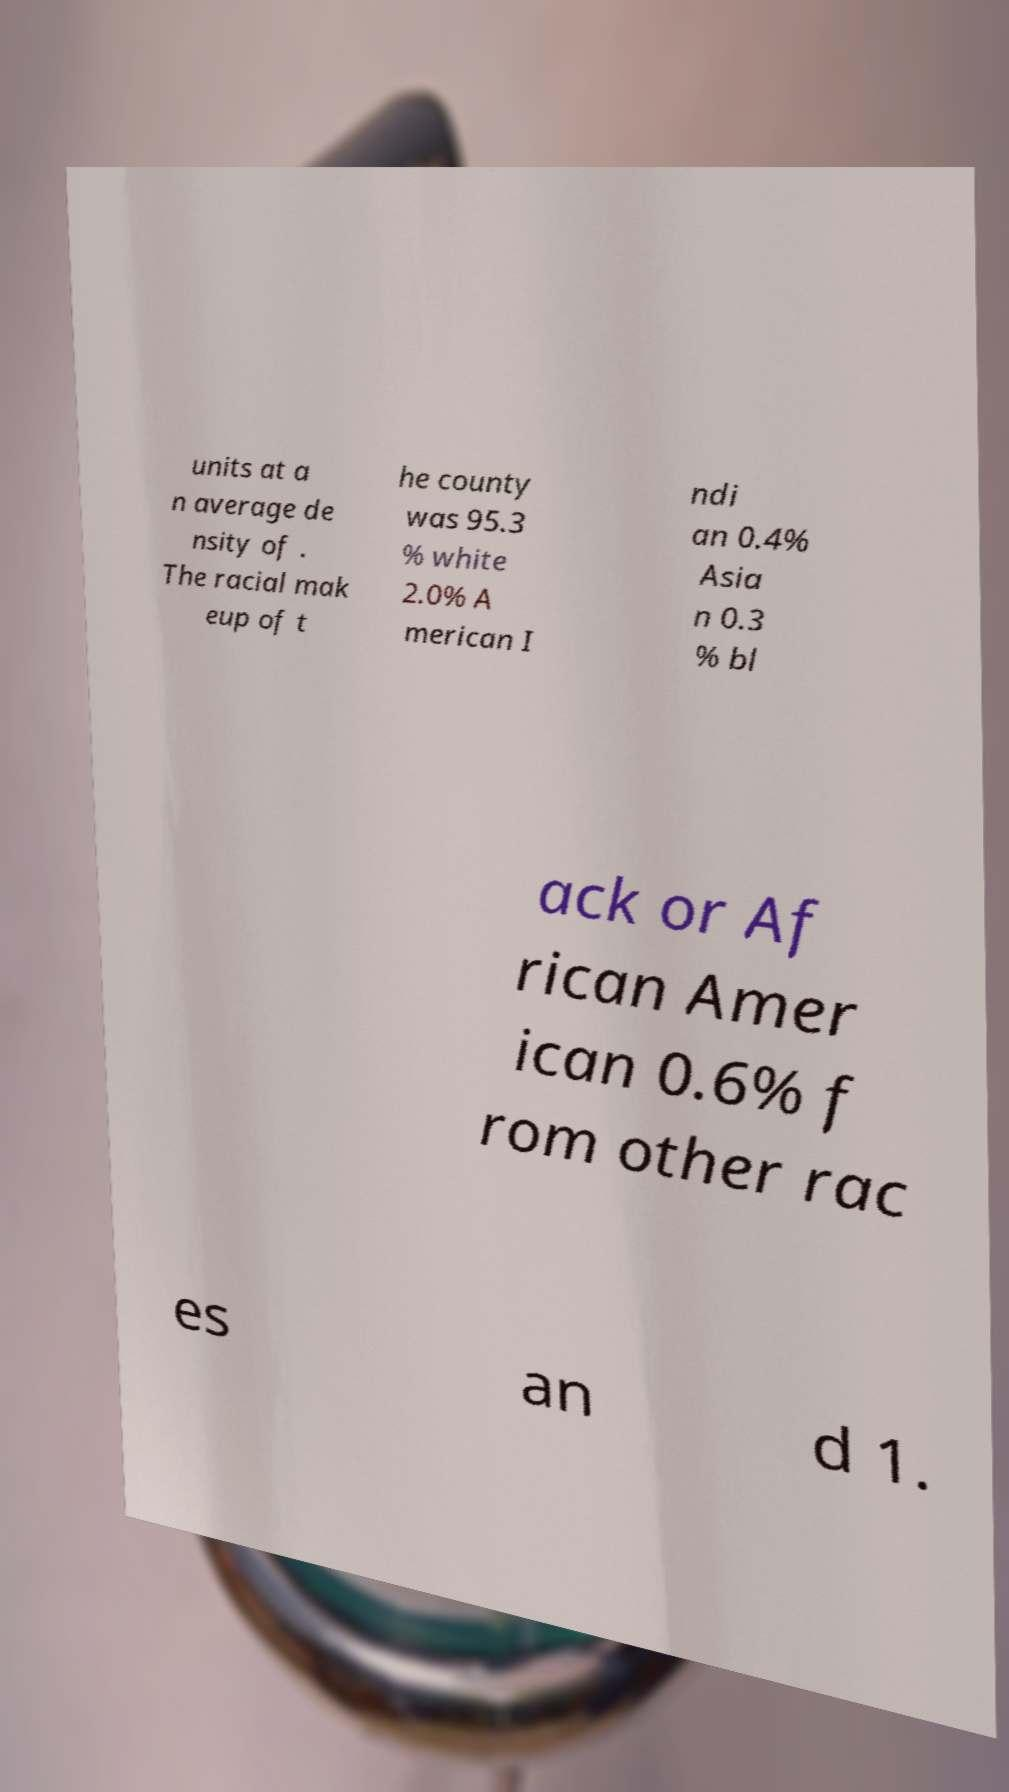There's text embedded in this image that I need extracted. Can you transcribe it verbatim? units at a n average de nsity of . The racial mak eup of t he county was 95.3 % white 2.0% A merican I ndi an 0.4% Asia n 0.3 % bl ack or Af rican Amer ican 0.6% f rom other rac es an d 1. 